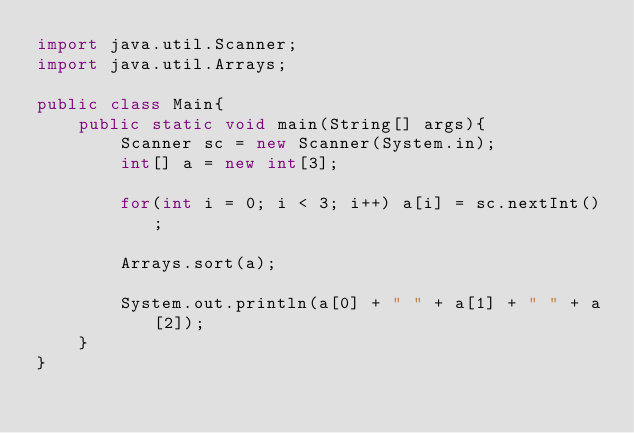Convert code to text. <code><loc_0><loc_0><loc_500><loc_500><_Java_>import java.util.Scanner;
import java.util.Arrays;

public class Main{
    public static void main(String[] args){
        Scanner sc = new Scanner(System.in);
        int[] a = new int[3];
        
        for(int i = 0; i < 3; i++) a[i] = sc.nextInt();

        Arrays.sort(a);
        
        System.out.println(a[0] + " " + a[1] + " " + a[2]);
    }
}</code> 